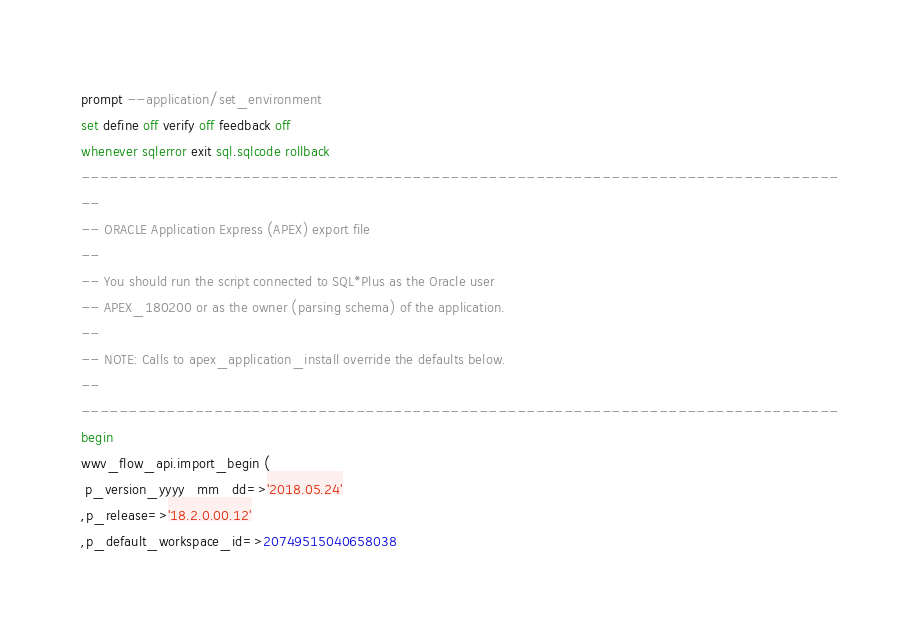Convert code to text. <code><loc_0><loc_0><loc_500><loc_500><_SQL_>prompt --application/set_environment
set define off verify off feedback off
whenever sqlerror exit sql.sqlcode rollback
--------------------------------------------------------------------------------
--
-- ORACLE Application Express (APEX) export file
--
-- You should run the script connected to SQL*Plus as the Oracle user
-- APEX_180200 or as the owner (parsing schema) of the application.
--
-- NOTE: Calls to apex_application_install override the defaults below.
--
--------------------------------------------------------------------------------
begin
wwv_flow_api.import_begin (
 p_version_yyyy_mm_dd=>'2018.05.24'
,p_release=>'18.2.0.00.12'
,p_default_workspace_id=>20749515040658038</code> 